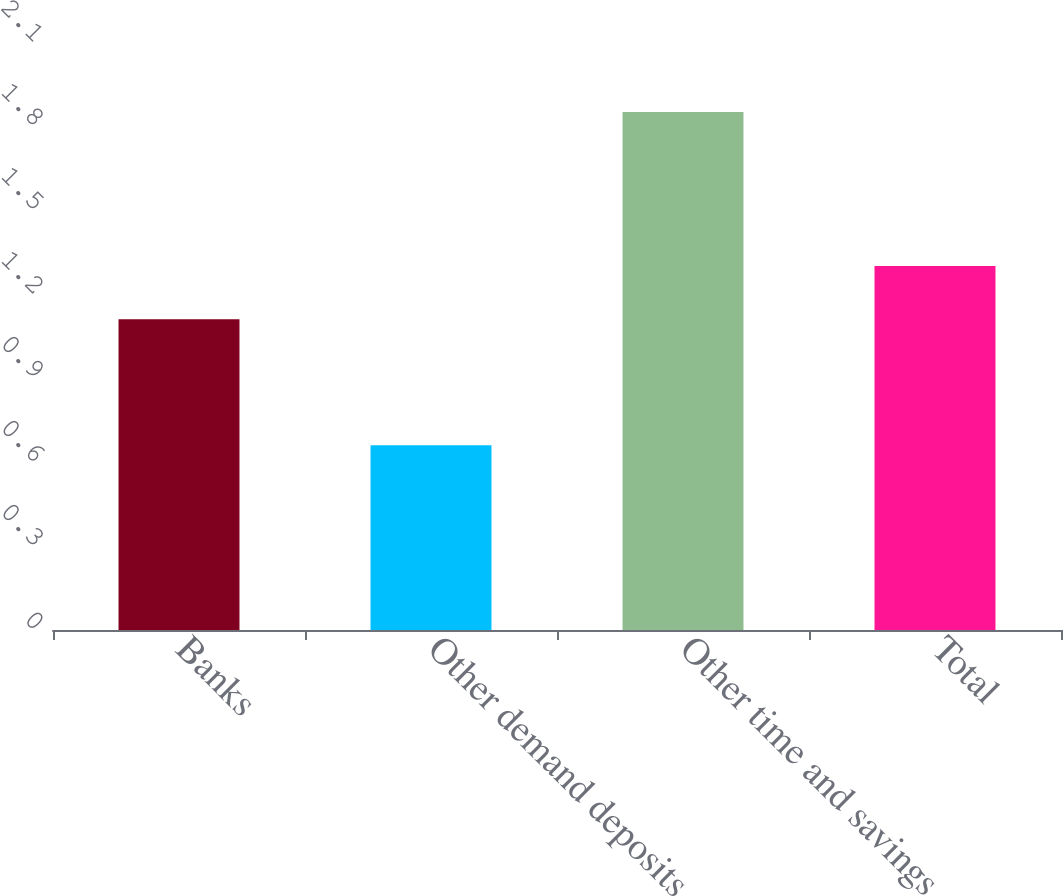Convert chart. <chart><loc_0><loc_0><loc_500><loc_500><bar_chart><fcel>Banks<fcel>Other demand deposits<fcel>Other time and savings<fcel>Total<nl><fcel>1.11<fcel>0.66<fcel>1.85<fcel>1.3<nl></chart> 